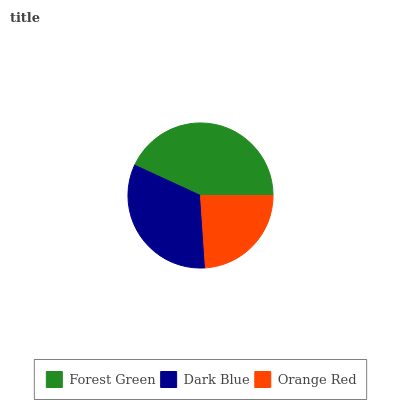Is Orange Red the minimum?
Answer yes or no. Yes. Is Forest Green the maximum?
Answer yes or no. Yes. Is Dark Blue the minimum?
Answer yes or no. No. Is Dark Blue the maximum?
Answer yes or no. No. Is Forest Green greater than Dark Blue?
Answer yes or no. Yes. Is Dark Blue less than Forest Green?
Answer yes or no. Yes. Is Dark Blue greater than Forest Green?
Answer yes or no. No. Is Forest Green less than Dark Blue?
Answer yes or no. No. Is Dark Blue the high median?
Answer yes or no. Yes. Is Dark Blue the low median?
Answer yes or no. Yes. Is Orange Red the high median?
Answer yes or no. No. Is Orange Red the low median?
Answer yes or no. No. 